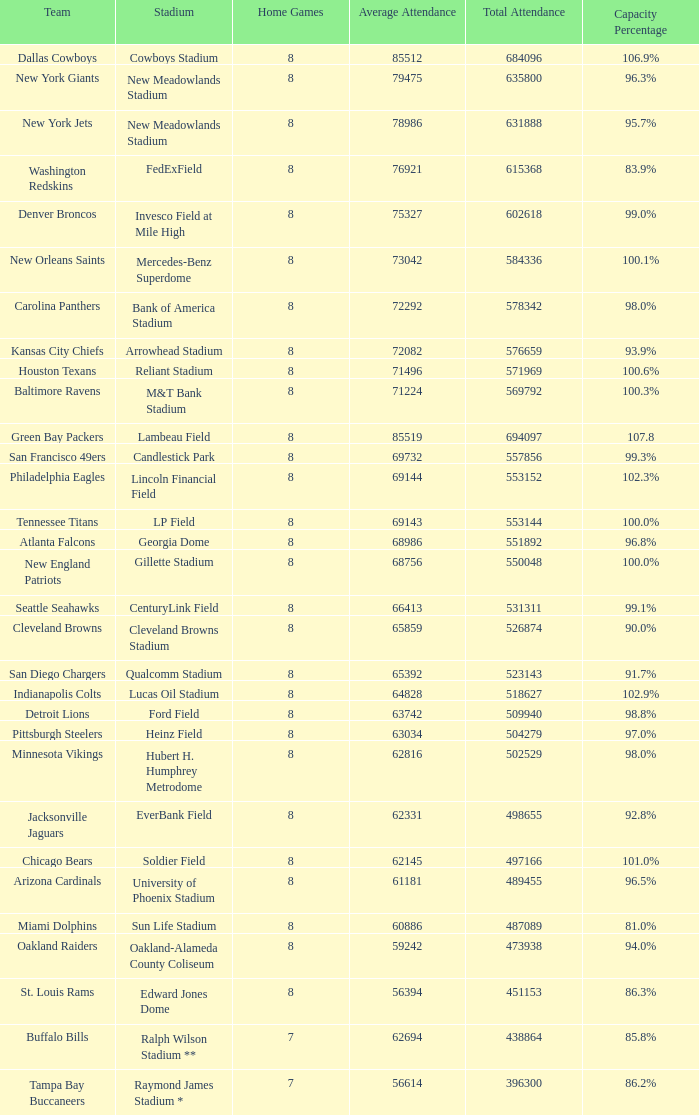What is the team's name when the arena is identified as edward jones dome? St. Louis Rams. 